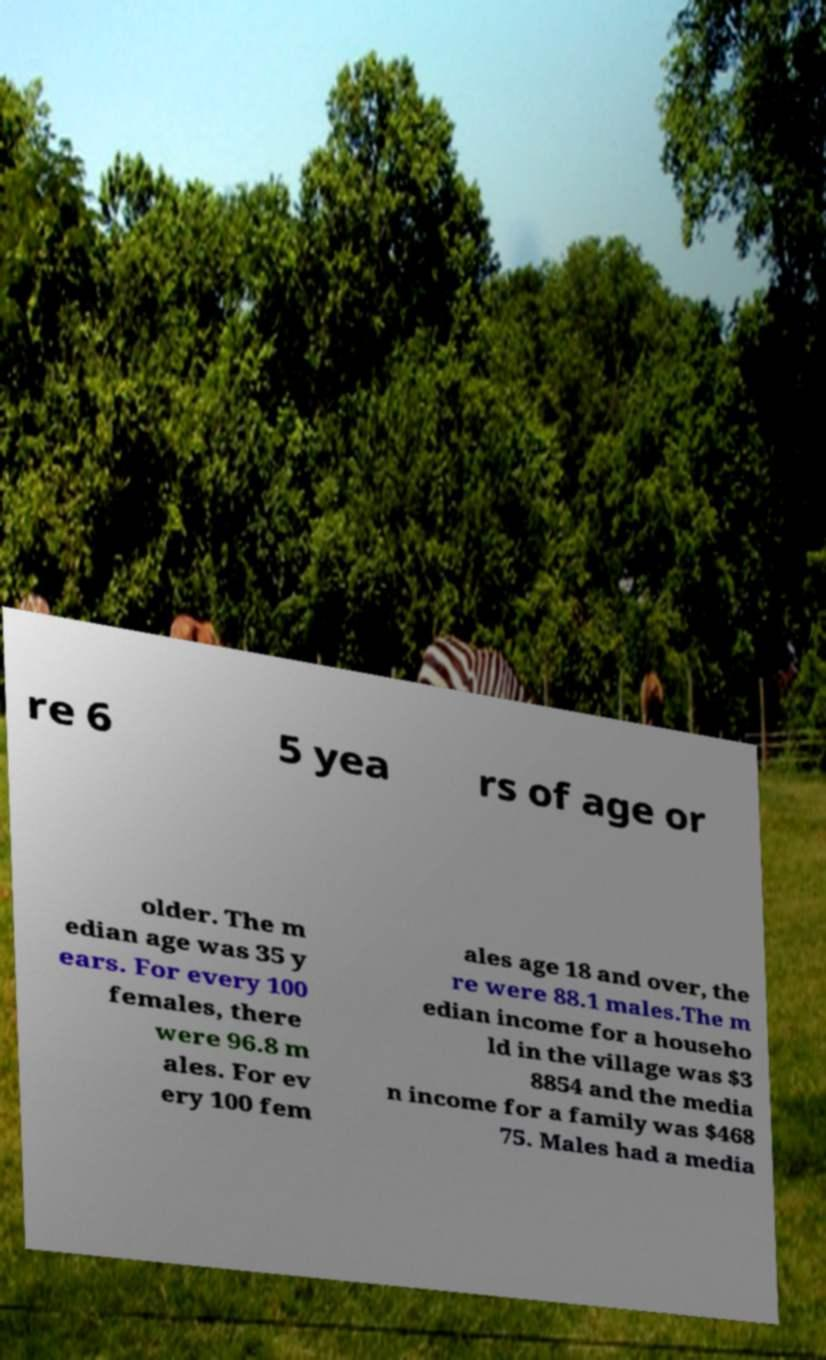Can you read and provide the text displayed in the image?This photo seems to have some interesting text. Can you extract and type it out for me? re 6 5 yea rs of age or older. The m edian age was 35 y ears. For every 100 females, there were 96.8 m ales. For ev ery 100 fem ales age 18 and over, the re were 88.1 males.The m edian income for a househo ld in the village was $3 8854 and the media n income for a family was $468 75. Males had a media 